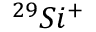<formula> <loc_0><loc_0><loc_500><loc_500>^ { 2 9 } S i ^ { + }</formula> 